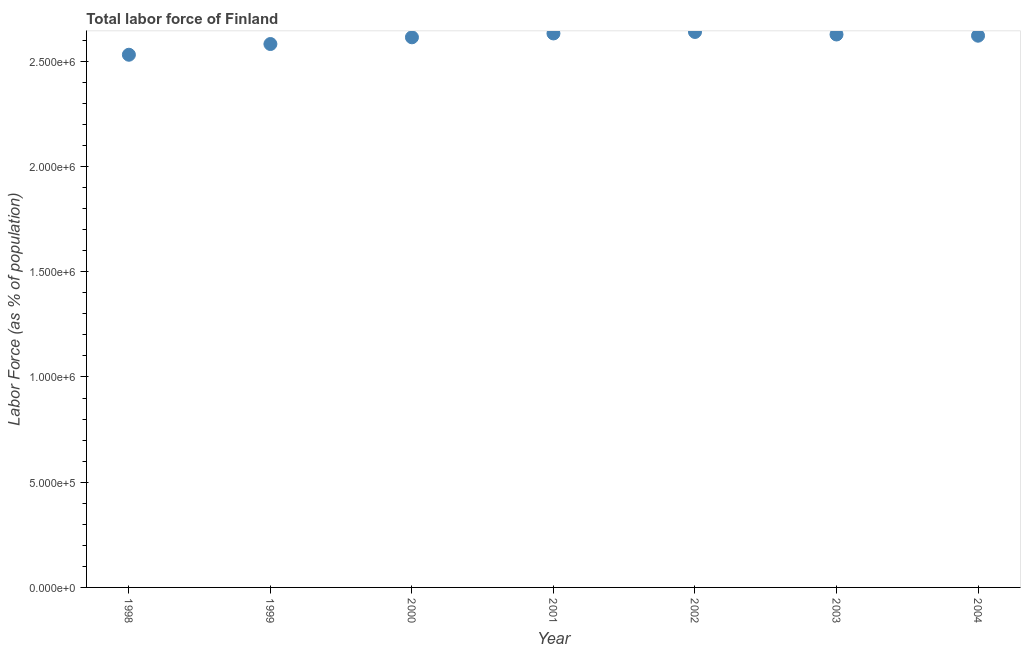What is the total labor force in 2003?
Give a very brief answer. 2.63e+06. Across all years, what is the maximum total labor force?
Make the answer very short. 2.64e+06. Across all years, what is the minimum total labor force?
Your answer should be compact. 2.53e+06. In which year was the total labor force maximum?
Keep it short and to the point. 2002. In which year was the total labor force minimum?
Make the answer very short. 1998. What is the sum of the total labor force?
Offer a very short reply. 1.82e+07. What is the difference between the total labor force in 1998 and 1999?
Make the answer very short. -5.09e+04. What is the average total labor force per year?
Provide a succinct answer. 2.61e+06. What is the median total labor force?
Give a very brief answer. 2.62e+06. In how many years, is the total labor force greater than 1500000 %?
Offer a terse response. 7. What is the ratio of the total labor force in 1998 to that in 1999?
Your answer should be very brief. 0.98. What is the difference between the highest and the second highest total labor force?
Ensure brevity in your answer.  7029. Is the sum of the total labor force in 2000 and 2004 greater than the maximum total labor force across all years?
Ensure brevity in your answer.  Yes. What is the difference between the highest and the lowest total labor force?
Offer a terse response. 1.08e+05. Does the total labor force monotonically increase over the years?
Give a very brief answer. No. What is the difference between two consecutive major ticks on the Y-axis?
Give a very brief answer. 5.00e+05. Does the graph contain grids?
Ensure brevity in your answer.  No. What is the title of the graph?
Give a very brief answer. Total labor force of Finland. What is the label or title of the Y-axis?
Offer a terse response. Labor Force (as % of population). What is the Labor Force (as % of population) in 1998?
Your answer should be compact. 2.53e+06. What is the Labor Force (as % of population) in 1999?
Offer a terse response. 2.58e+06. What is the Labor Force (as % of population) in 2000?
Keep it short and to the point. 2.61e+06. What is the Labor Force (as % of population) in 2001?
Your response must be concise. 2.63e+06. What is the Labor Force (as % of population) in 2002?
Provide a succinct answer. 2.64e+06. What is the Labor Force (as % of population) in 2003?
Provide a succinct answer. 2.63e+06. What is the Labor Force (as % of population) in 2004?
Give a very brief answer. 2.62e+06. What is the difference between the Labor Force (as % of population) in 1998 and 1999?
Offer a terse response. -5.09e+04. What is the difference between the Labor Force (as % of population) in 1998 and 2000?
Ensure brevity in your answer.  -8.28e+04. What is the difference between the Labor Force (as % of population) in 1998 and 2001?
Give a very brief answer. -1.01e+05. What is the difference between the Labor Force (as % of population) in 1998 and 2002?
Your answer should be compact. -1.08e+05. What is the difference between the Labor Force (as % of population) in 1998 and 2003?
Your response must be concise. -9.63e+04. What is the difference between the Labor Force (as % of population) in 1998 and 2004?
Provide a succinct answer. -9.05e+04. What is the difference between the Labor Force (as % of population) in 1999 and 2000?
Offer a very short reply. -3.19e+04. What is the difference between the Labor Force (as % of population) in 1999 and 2001?
Ensure brevity in your answer.  -5.03e+04. What is the difference between the Labor Force (as % of population) in 1999 and 2002?
Ensure brevity in your answer.  -5.73e+04. What is the difference between the Labor Force (as % of population) in 1999 and 2003?
Offer a terse response. -4.53e+04. What is the difference between the Labor Force (as % of population) in 1999 and 2004?
Provide a succinct answer. -3.95e+04. What is the difference between the Labor Force (as % of population) in 2000 and 2001?
Give a very brief answer. -1.84e+04. What is the difference between the Labor Force (as % of population) in 2000 and 2002?
Offer a terse response. -2.54e+04. What is the difference between the Labor Force (as % of population) in 2000 and 2003?
Make the answer very short. -1.34e+04. What is the difference between the Labor Force (as % of population) in 2000 and 2004?
Make the answer very short. -7622. What is the difference between the Labor Force (as % of population) in 2001 and 2002?
Give a very brief answer. -7029. What is the difference between the Labor Force (as % of population) in 2001 and 2003?
Make the answer very short. 4950. What is the difference between the Labor Force (as % of population) in 2001 and 2004?
Keep it short and to the point. 1.08e+04. What is the difference between the Labor Force (as % of population) in 2002 and 2003?
Offer a terse response. 1.20e+04. What is the difference between the Labor Force (as % of population) in 2002 and 2004?
Ensure brevity in your answer.  1.78e+04. What is the difference between the Labor Force (as % of population) in 2003 and 2004?
Give a very brief answer. 5801. What is the ratio of the Labor Force (as % of population) in 1998 to that in 2001?
Provide a succinct answer. 0.96. What is the ratio of the Labor Force (as % of population) in 1998 to that in 2003?
Give a very brief answer. 0.96. What is the ratio of the Labor Force (as % of population) in 1999 to that in 2002?
Ensure brevity in your answer.  0.98. What is the ratio of the Labor Force (as % of population) in 1999 to that in 2003?
Offer a terse response. 0.98. What is the ratio of the Labor Force (as % of population) in 2000 to that in 2001?
Keep it short and to the point. 0.99. What is the ratio of the Labor Force (as % of population) in 2001 to that in 2003?
Keep it short and to the point. 1. What is the ratio of the Labor Force (as % of population) in 2002 to that in 2003?
Your answer should be compact. 1. What is the ratio of the Labor Force (as % of population) in 2003 to that in 2004?
Your answer should be very brief. 1. 